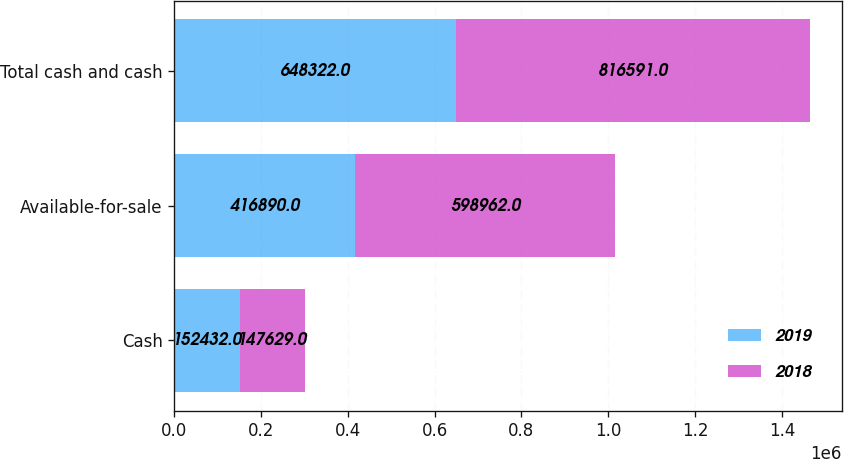<chart> <loc_0><loc_0><loc_500><loc_500><stacked_bar_chart><ecel><fcel>Cash<fcel>Available-for-sale<fcel>Total cash and cash<nl><fcel>2019<fcel>152432<fcel>416890<fcel>648322<nl><fcel>2018<fcel>147629<fcel>598962<fcel>816591<nl></chart> 